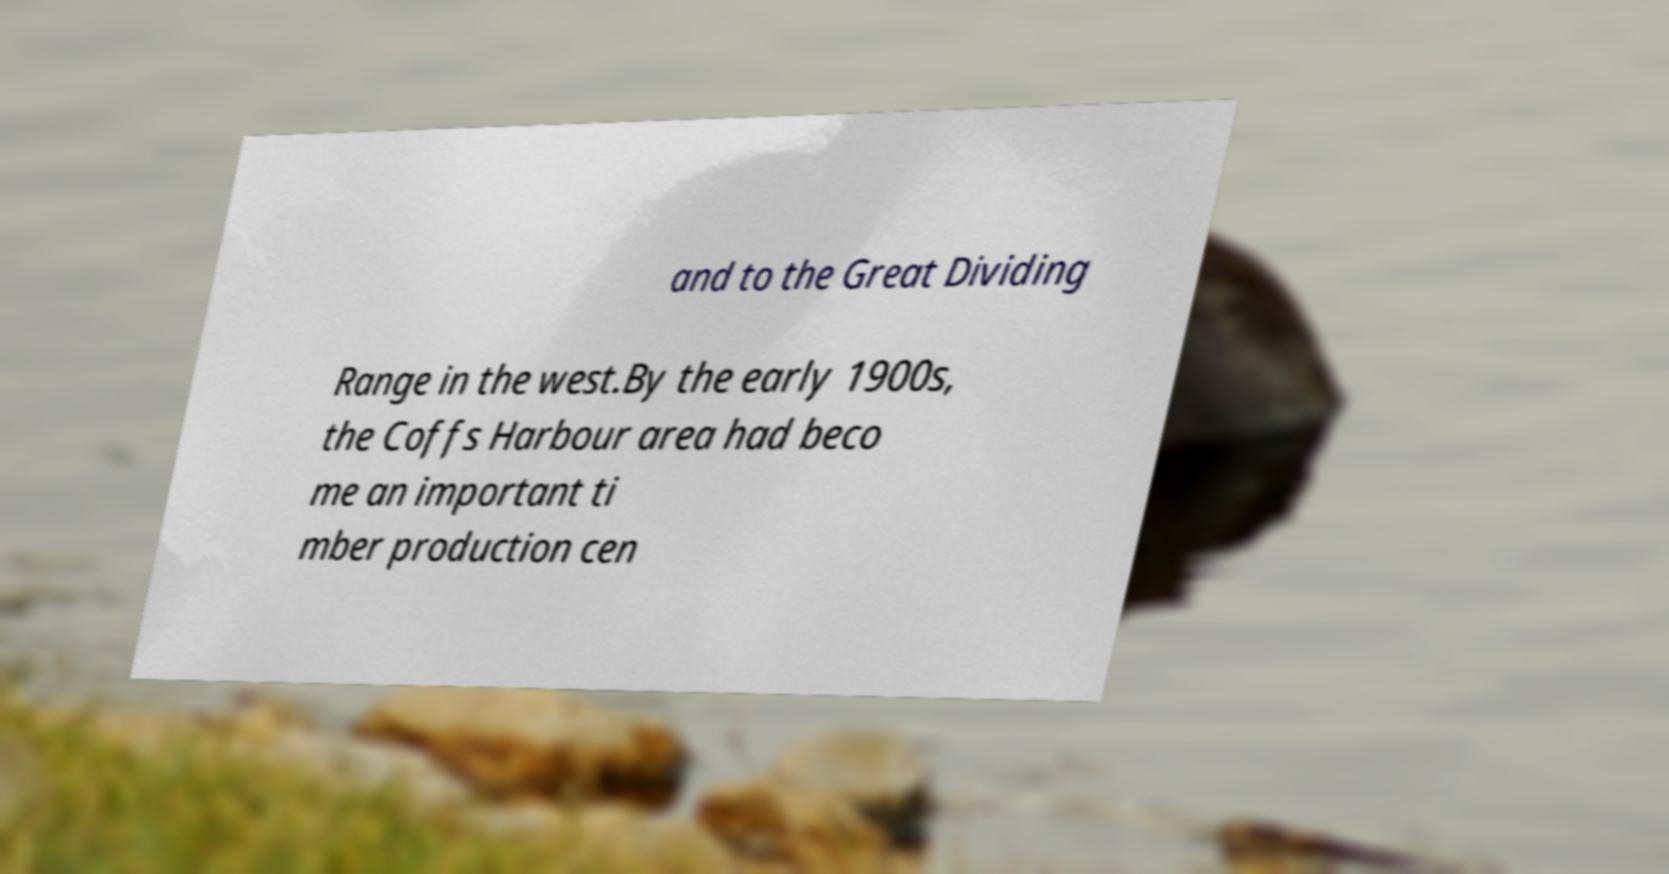Can you read and provide the text displayed in the image?This photo seems to have some interesting text. Can you extract and type it out for me? and to the Great Dividing Range in the west.By the early 1900s, the Coffs Harbour area had beco me an important ti mber production cen 